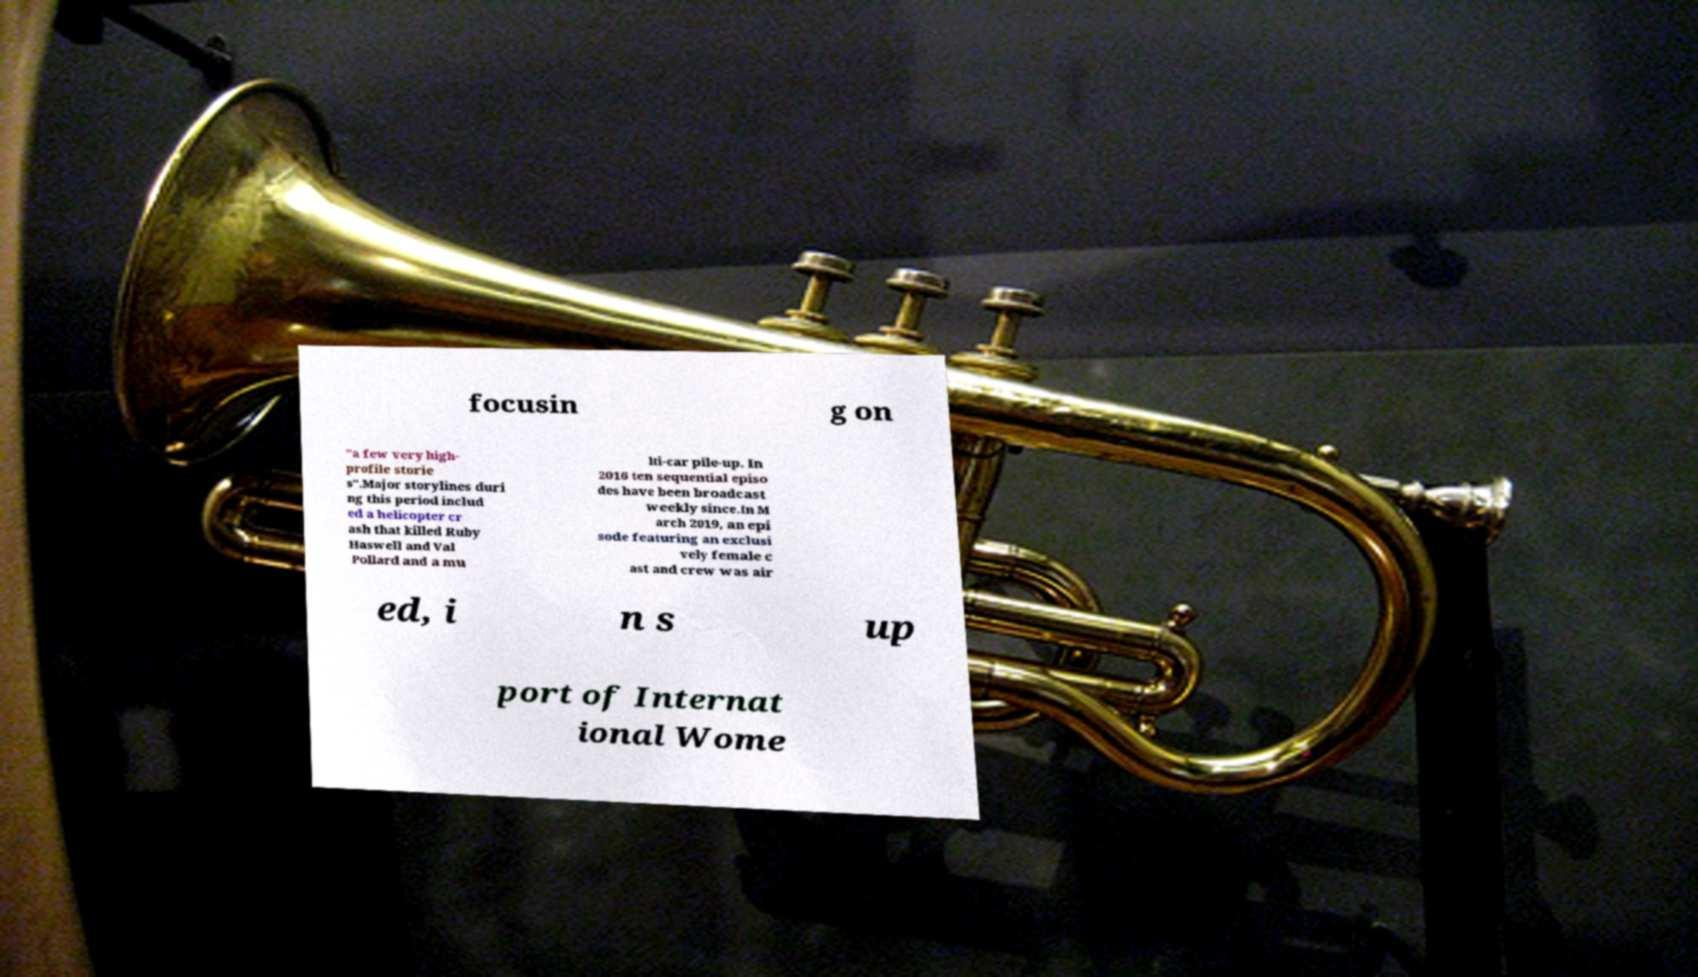What messages or text are displayed in this image? I need them in a readable, typed format. focusin g on "a few very high- profile storie s".Major storylines duri ng this period includ ed a helicopter cr ash that killed Ruby Haswell and Val Pollard and a mu lti-car pile-up. In 2016 ten sequential episo des have been broadcast weekly since.In M arch 2019, an epi sode featuring an exclusi vely female c ast and crew was air ed, i n s up port of Internat ional Wome 